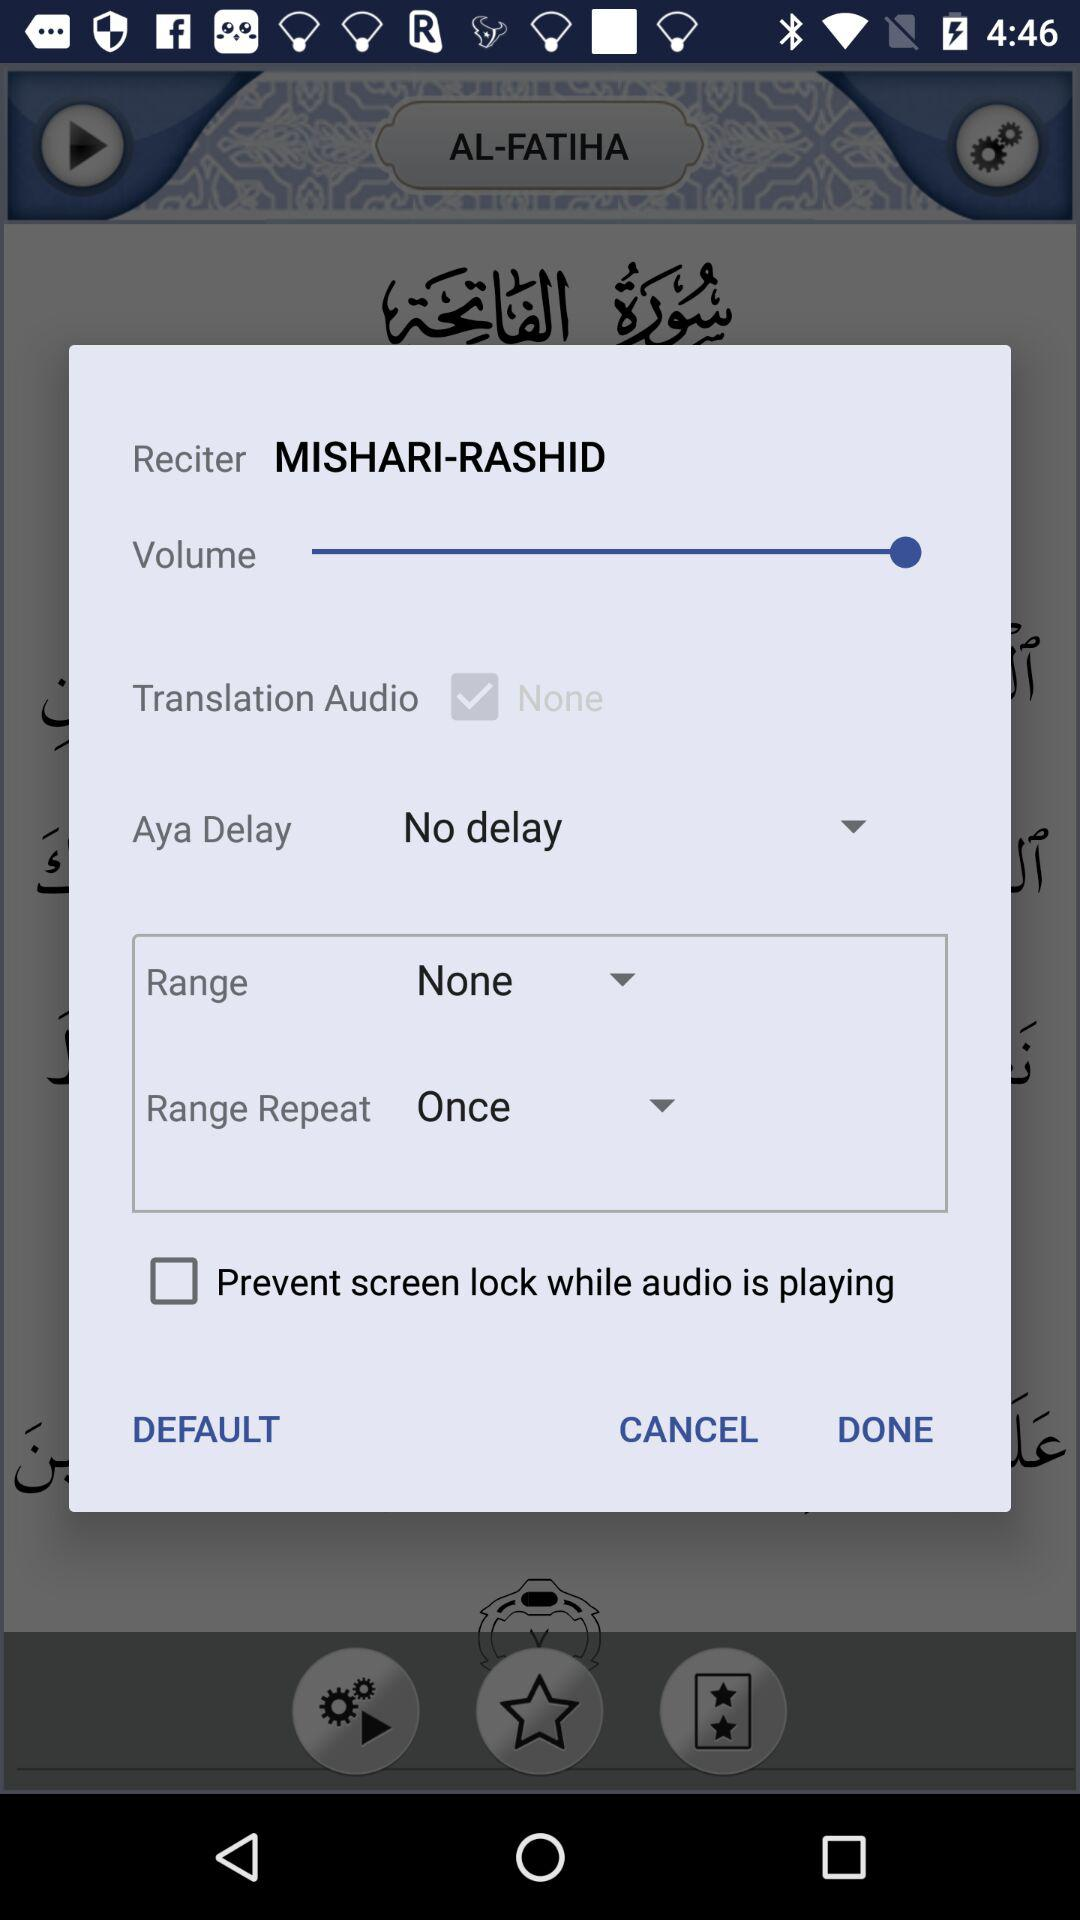Which option is selected for range? The selected option is "None". 